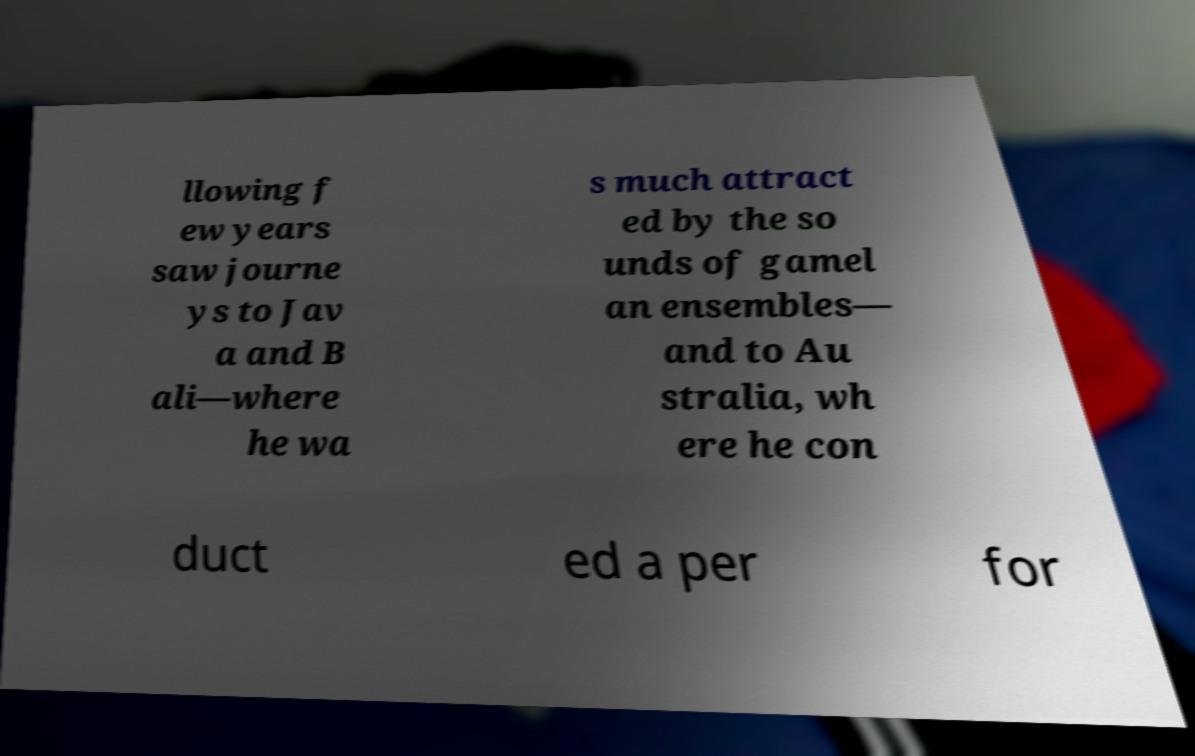Could you assist in decoding the text presented in this image and type it out clearly? llowing f ew years saw journe ys to Jav a and B ali—where he wa s much attract ed by the so unds of gamel an ensembles— and to Au stralia, wh ere he con duct ed a per for 